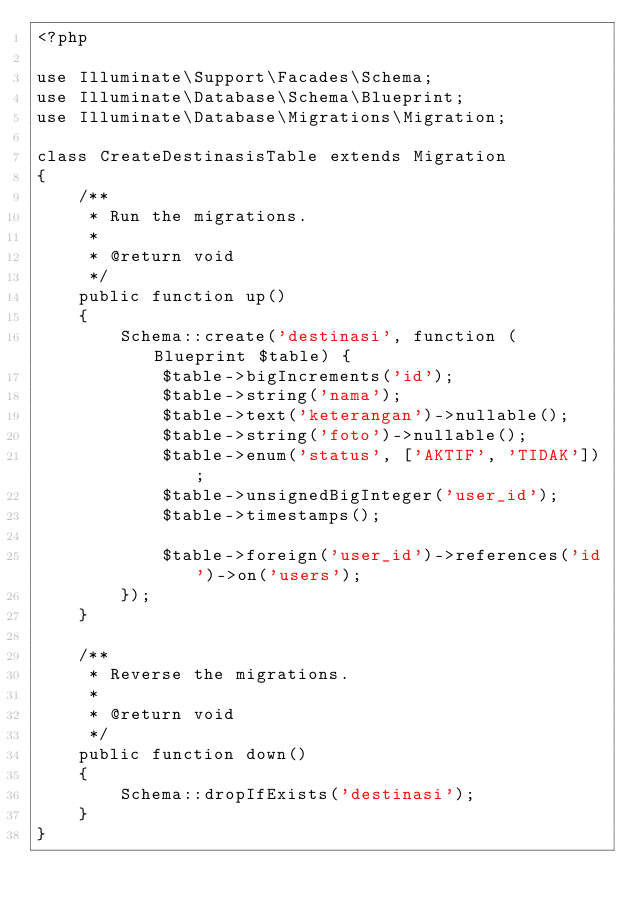<code> <loc_0><loc_0><loc_500><loc_500><_PHP_><?php

use Illuminate\Support\Facades\Schema;
use Illuminate\Database\Schema\Blueprint;
use Illuminate\Database\Migrations\Migration;

class CreateDestinasisTable extends Migration
{
    /**
     * Run the migrations.
     *
     * @return void
     */
    public function up()
    {
        Schema::create('destinasi', function (Blueprint $table) {
            $table->bigIncrements('id');
            $table->string('nama');
            $table->text('keterangan')->nullable();
            $table->string('foto')->nullable();
            $table->enum('status', ['AKTIF', 'TIDAK']);            
            $table->unsignedBigInteger('user_id');            
            $table->timestamps();

            $table->foreign('user_id')->references('id')->on('users');
        });
    }

    /**
     * Reverse the migrations.
     *
     * @return void
     */
    public function down()
    {
        Schema::dropIfExists('destinasi');
    }
}
</code> 